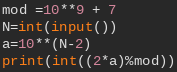<code> <loc_0><loc_0><loc_500><loc_500><_Python_>mod =10**9 + 7
N=int(input())
a=10**(N-2)
print(int((2*a)%mod))</code> 